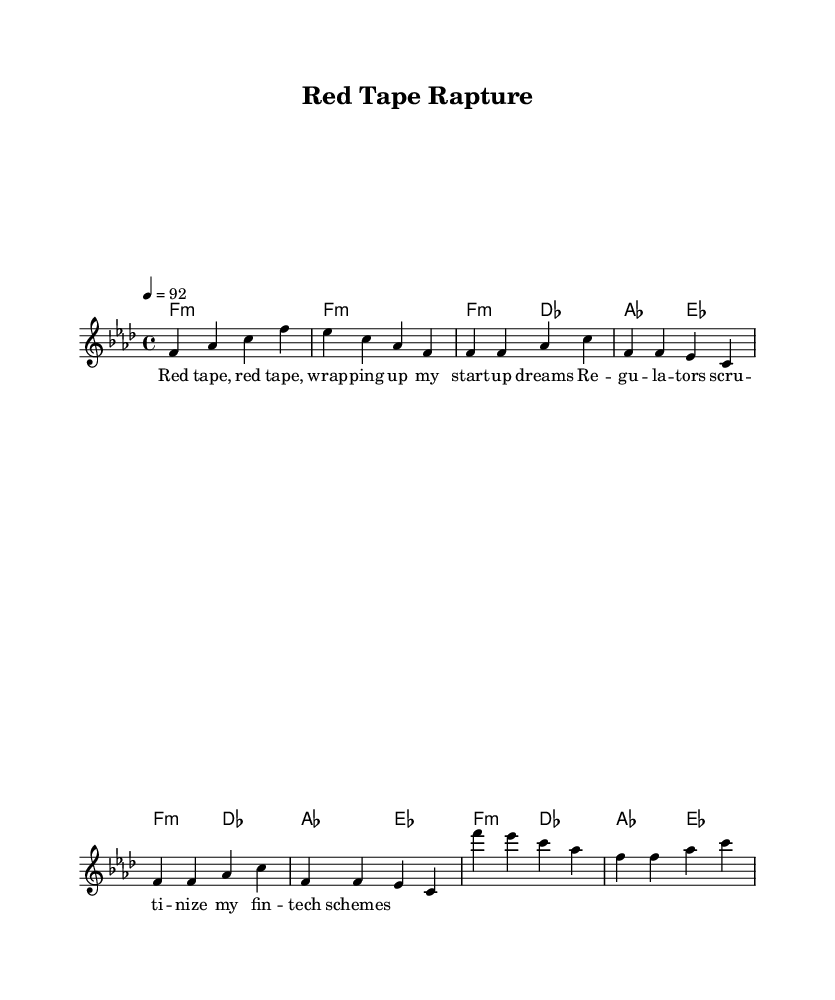What is the key signature of this music? The key signature is indicated by the presence of the B flat and E flat notes. This corresponds to F minor, which has four flats.
Answer: F minor What is the time signature of this piece? The time signature appears at the beginning of the sheet music, displayed as 4/4, indicating four beats per measure.
Answer: 4/4 What is the tempo marking for this piece? The tempo marking is shown in the score as '4 = 92', which indicates the beats per minute.
Answer: 92 What is the name of the piece? The title is given at the top of the sheet music under the header section, stating "Red Tape Rapture."
Answer: Red Tape Rapture How many measures are in the verse section? The verse section consists of two repetitions of a set of measures, each with four measures, totaling eight measures.
Answer: 8 What is the predominant theme of the lyrics? The lyrics reflect the challenges faced by startups due to regulatory scrutiny, focusing on the metaphor of 'red tape.'
Answer: Regulatory hurdles What musical form does this piece exhibit? The piece has a clear structure with an introduction, verse, and chorus, following a common hip-hop format for songs with a repeated hook.
Answer: Verse-Chorus form 